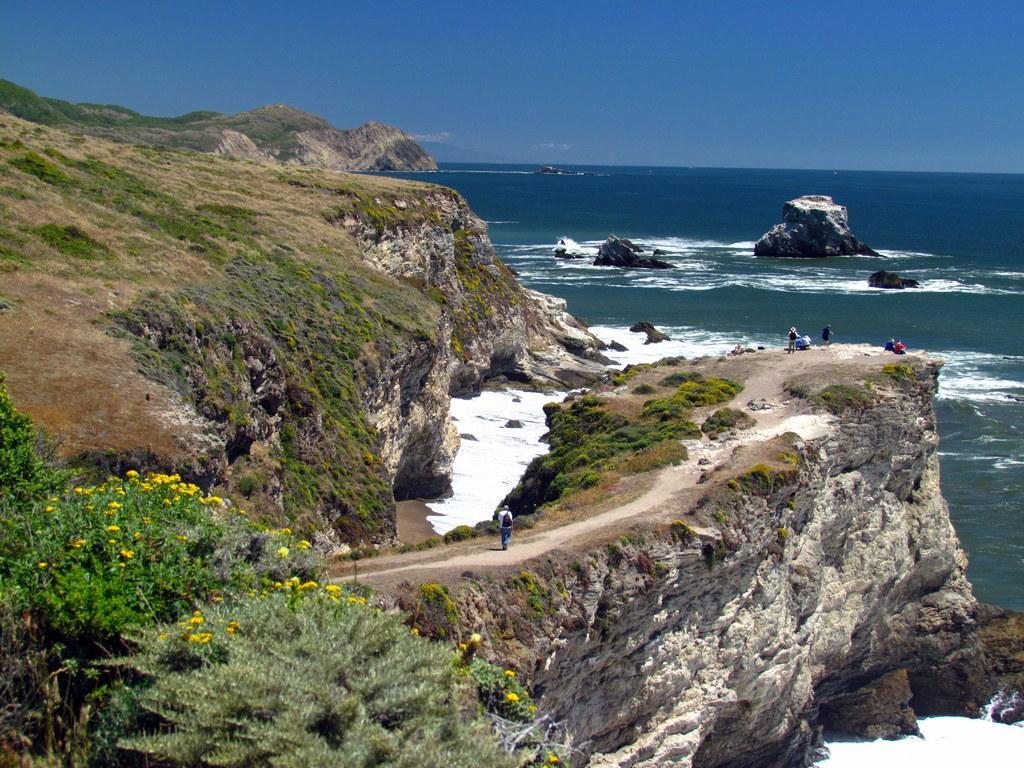Please provide a concise description of this image. In this image on the left side we can see plants with flowers and there are few persons on the cliff. In the background we can see rocks in the water, cliff and clouds in the sky. 